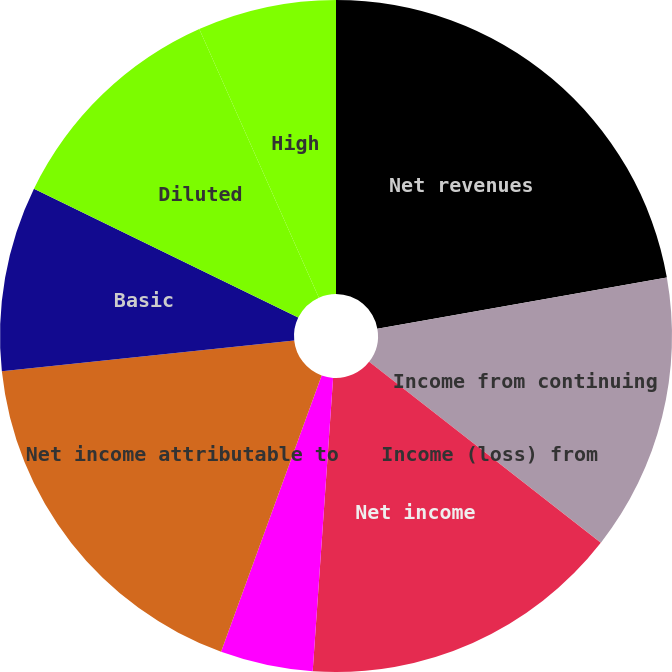<chart> <loc_0><loc_0><loc_500><loc_500><pie_chart><fcel>Net revenues<fcel>Income from continuing<fcel>Income (loss) from<fcel>Net income<fcel>Less Net income (loss)<fcel>Net income attributable to<fcel>Basic<fcel>Diluted<fcel>High<nl><fcel>22.21%<fcel>13.33%<fcel>0.01%<fcel>15.55%<fcel>4.45%<fcel>17.77%<fcel>8.89%<fcel>11.11%<fcel>6.67%<nl></chart> 